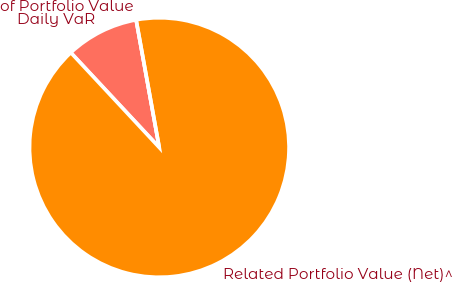Convert chart to OTSL. <chart><loc_0><loc_0><loc_500><loc_500><pie_chart><fcel>Daily VaR<fcel>Related Portfolio Value (Net)^<fcel>of Portfolio Value<nl><fcel>9.09%<fcel>90.91%<fcel>0.0%<nl></chart> 